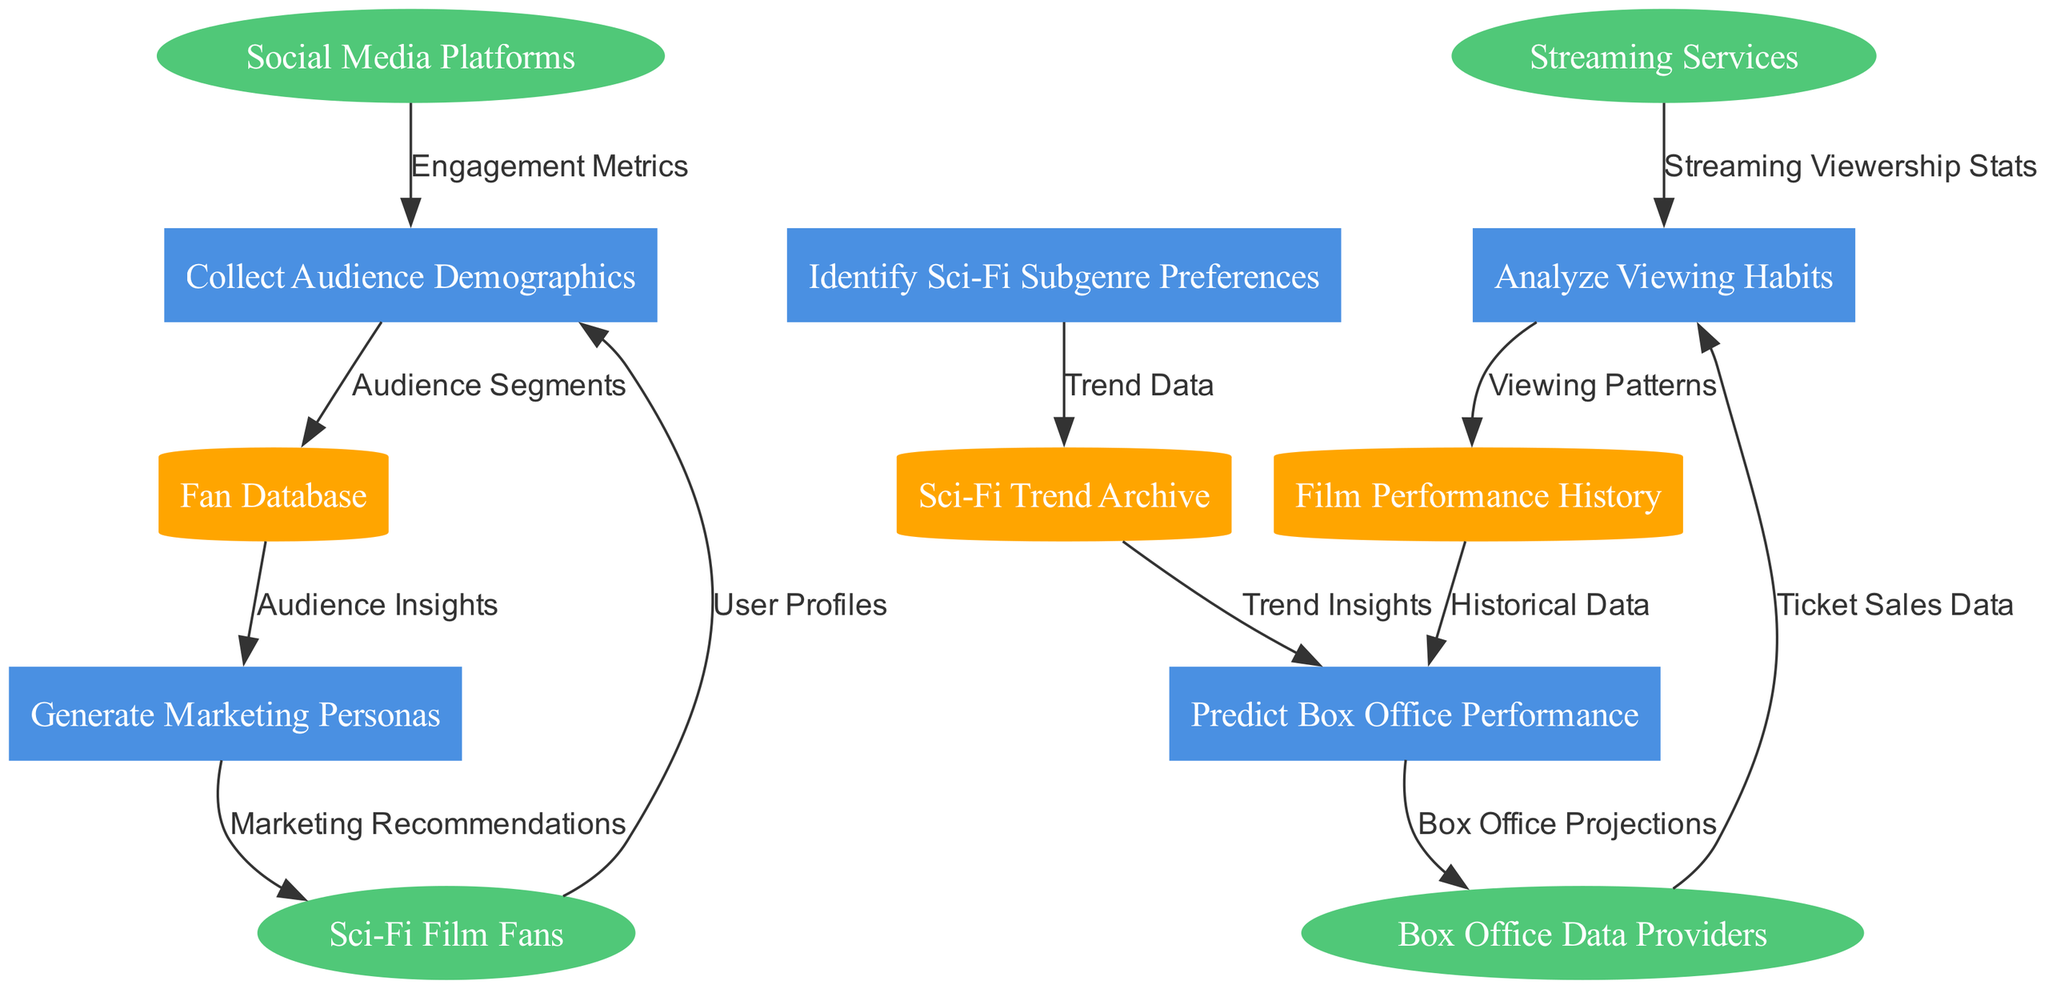What are the external entities in this diagram? The external entities listed in the diagram include Sci-Fi Film Fans, Social Media Platforms, Box Office Data Providers, and Streaming Services. These entities interact with the processes in the diagram.
Answer: Sci-Fi Film Fans, Social Media Platforms, Box Office Data Providers, Streaming Services How many processes are depicted in the diagram? The diagram includes five processes, which are Collect Audience Demographics, Analyze Viewing Habits, Identify Sci-Fi Subgenre Preferences, Generate Marketing Personas, and Predict Box Office Performance. Counting them gives us the total.
Answer: 5 Which process is linked to the Sci-Fi Trend Archive? The process Identify Sci-Fi Subgenre Preferences is linked to the Sci-Fi Trend Archive. This connection indicates that the subgenre preferences rely on the trend data stored in the archive.
Answer: Identify Sci-Fi Subgenre Preferences What type of data flow connects Streaming Services to analyze viewing habits? The data flow connecting Streaming Services to the Analyze Viewing Habits process is labeled Streaming Viewership Stats. This flow reflects the data being collected from streaming services regarding viewership.
Answer: Streaming Viewership Stats Which data store is used for generating marketing personas? The Fan Database is used for generating marketing personas. This indicates that insights gained from the fan database contribute to creating targeted marketing profiles.
Answer: Fan Database How are marketing recommendations derived in the diagram? Marketing recommendations are derived from the Generate Marketing Personas process, which, in turn, is influenced by insights from the Fan Database. Therefore, it relies on both the marketing persona generation and the database insights to make recommendations.
Answer: Generate Marketing Personas What is the output of the Predict Box Office Performance process? The output of the Predict Box Office Performance process is Box Office Projections. This output indicates the predicted financial performance of the films based on data processed through the various previous steps in the diagram.
Answer: Box Office Projections How does the data flow from the Fan Database and Film Performance History connect in the diagram? The Fan Database data flows into the Generate Marketing Personas process, providing audience insights, while the Film Performance History data flows into the Predict Box Office Performance process, offering historical data, which indicates that each serves a different end process through their respective data flows.
Answer: Different end processes 